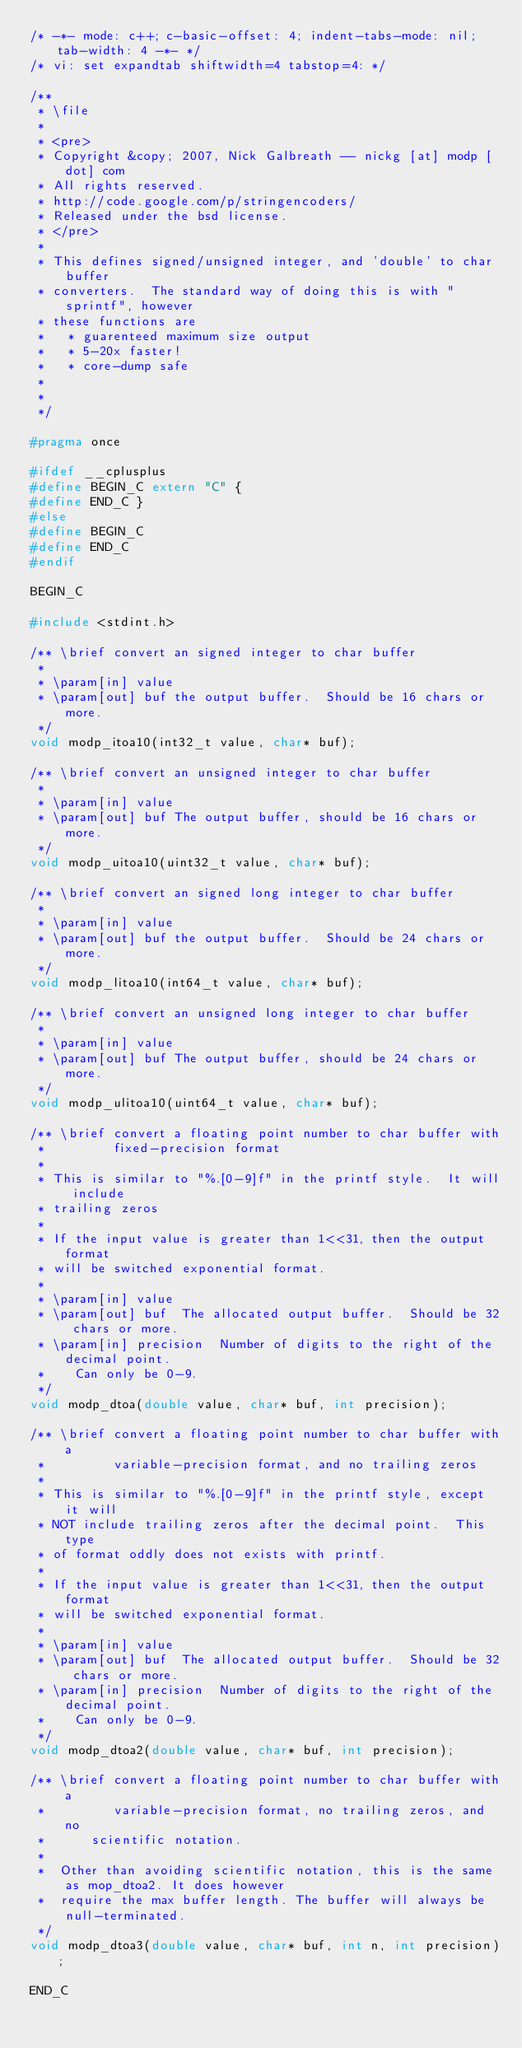<code> <loc_0><loc_0><loc_500><loc_500><_C_>/* -*- mode: c++; c-basic-offset: 4; indent-tabs-mode: nil; tab-width: 4 -*- */
/* vi: set expandtab shiftwidth=4 tabstop=4: */

/**
 * \file
 *
 * <pre>
 * Copyright &copy; 2007, Nick Galbreath -- nickg [at] modp [dot] com
 * All rights reserved.
 * http://code.google.com/p/stringencoders/
 * Released under the bsd license.
 * </pre>
 *
 * This defines signed/unsigned integer, and 'double' to char buffer
 * converters.  The standard way of doing this is with "sprintf", however
 * these functions are
 *   * guarenteed maximum size output
 *   * 5-20x faster!
 *   * core-dump safe
 *
 *
 */

#pragma once

#ifdef __cplusplus
#define BEGIN_C extern "C" {
#define END_C }
#else
#define BEGIN_C
#define END_C
#endif

BEGIN_C

#include <stdint.h>

/** \brief convert an signed integer to char buffer
 *
 * \param[in] value
 * \param[out] buf the output buffer.  Should be 16 chars or more.
 */
void modp_itoa10(int32_t value, char* buf);

/** \brief convert an unsigned integer to char buffer
 *
 * \param[in] value
 * \param[out] buf The output buffer, should be 16 chars or more.
 */
void modp_uitoa10(uint32_t value, char* buf);

/** \brief convert an signed long integer to char buffer
 *
 * \param[in] value
 * \param[out] buf the output buffer.  Should be 24 chars or more.
 */
void modp_litoa10(int64_t value, char* buf);

/** \brief convert an unsigned long integer to char buffer
 *
 * \param[in] value
 * \param[out] buf The output buffer, should be 24 chars or more.
 */
void modp_ulitoa10(uint64_t value, char* buf);

/** \brief convert a floating point number to char buffer with
 *         fixed-precision format
 *
 * This is similar to "%.[0-9]f" in the printf style.  It will include
 * trailing zeros
 *
 * If the input value is greater than 1<<31, then the output format
 * will be switched exponential format.
 *
 * \param[in] value
 * \param[out] buf  The allocated output buffer.  Should be 32 chars or more.
 * \param[in] precision  Number of digits to the right of the decimal point.
 *    Can only be 0-9.
 */
void modp_dtoa(double value, char* buf, int precision);

/** \brief convert a floating point number to char buffer with a
 *         variable-precision format, and no trailing zeros
 *
 * This is similar to "%.[0-9]f" in the printf style, except it will
 * NOT include trailing zeros after the decimal point.  This type
 * of format oddly does not exists with printf.
 *
 * If the input value is greater than 1<<31, then the output format
 * will be switched exponential format.
 *
 * \param[in] value
 * \param[out] buf  The allocated output buffer.  Should be 32 chars or more.
 * \param[in] precision  Number of digits to the right of the decimal point.
 *    Can only be 0-9.
 */
void modp_dtoa2(double value, char* buf, int precision);

/** \brief convert a floating point number to char buffer with a
 *         variable-precision format, no trailing zeros, and no
 *   	scientific notation.
 *
 *  Other than avoiding scientific notation, this is the same as mop_dtoa2. It does however
 *  require the max buffer length. The buffer will always be null-terminated.
 */
void modp_dtoa3(double value, char* buf, int n, int precision);

END_C
</code> 